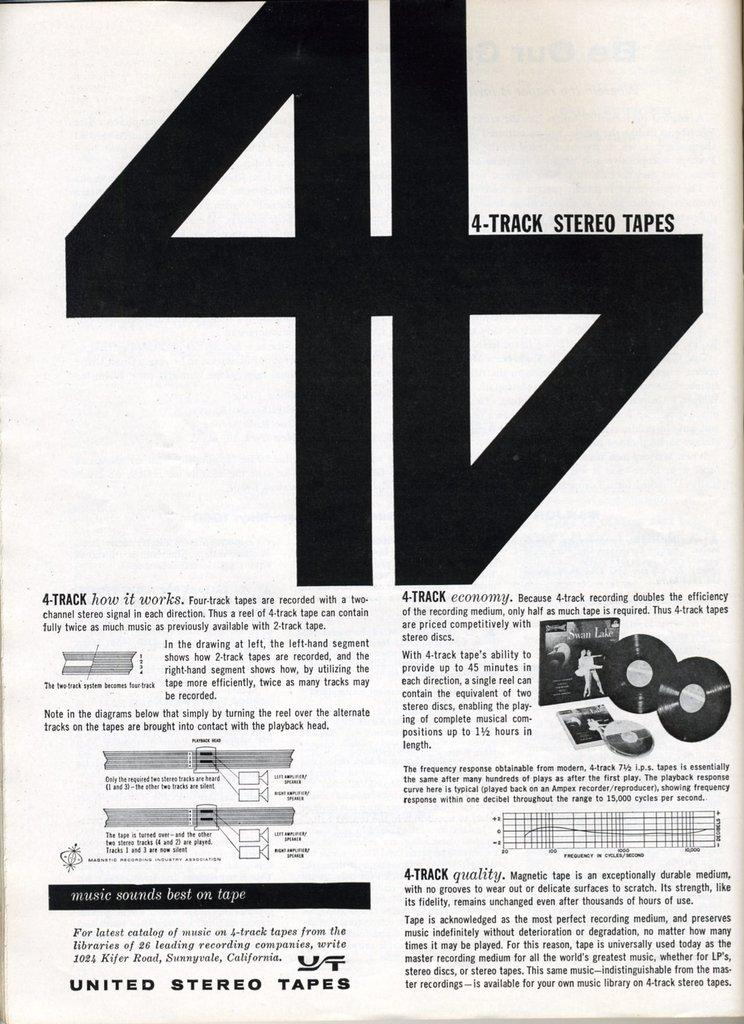<image>
Relay a brief, clear account of the picture shown. A how to about 4 track tapes with a big number four on it. 